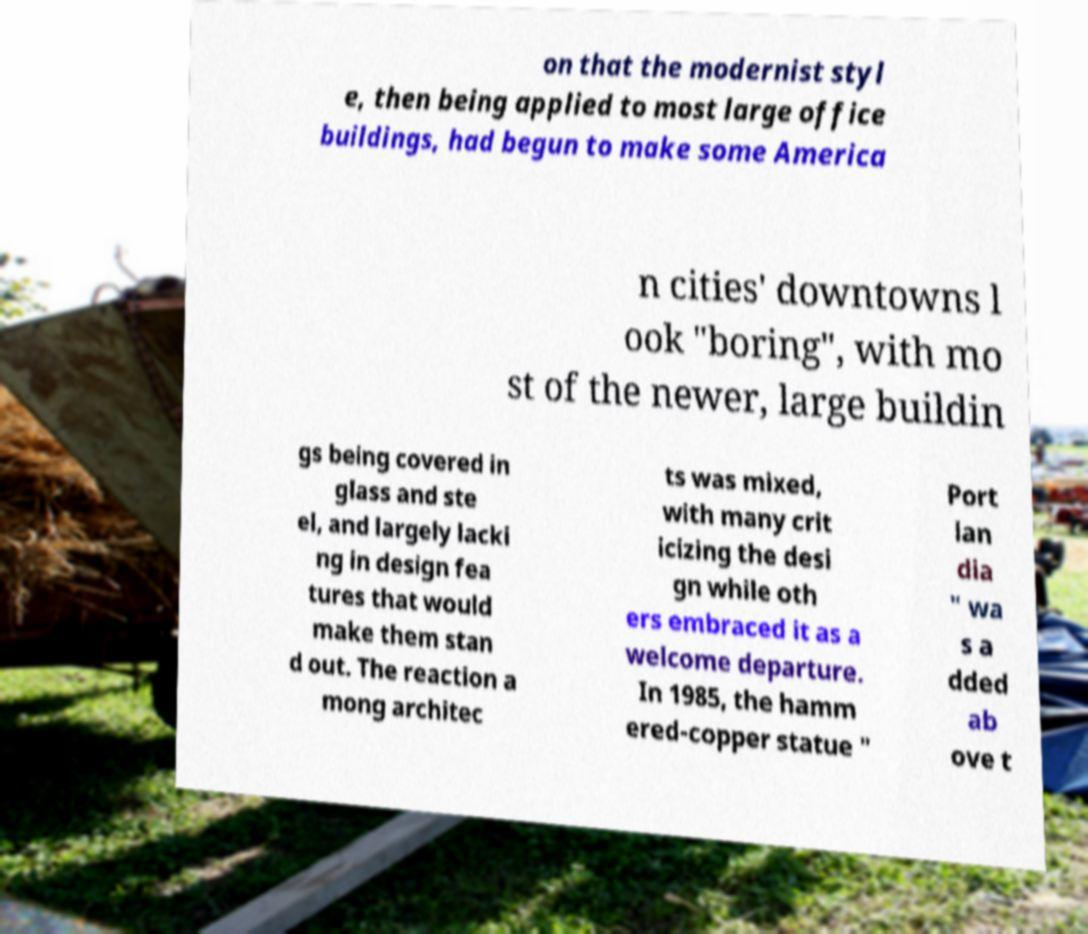Can you accurately transcribe the text from the provided image for me? on that the modernist styl e, then being applied to most large office buildings, had begun to make some America n cities' downtowns l ook "boring", with mo st of the newer, large buildin gs being covered in glass and ste el, and largely lacki ng in design fea tures that would make them stan d out. The reaction a mong architec ts was mixed, with many crit icizing the desi gn while oth ers embraced it as a welcome departure. In 1985, the hamm ered-copper statue " Port lan dia " wa s a dded ab ove t 